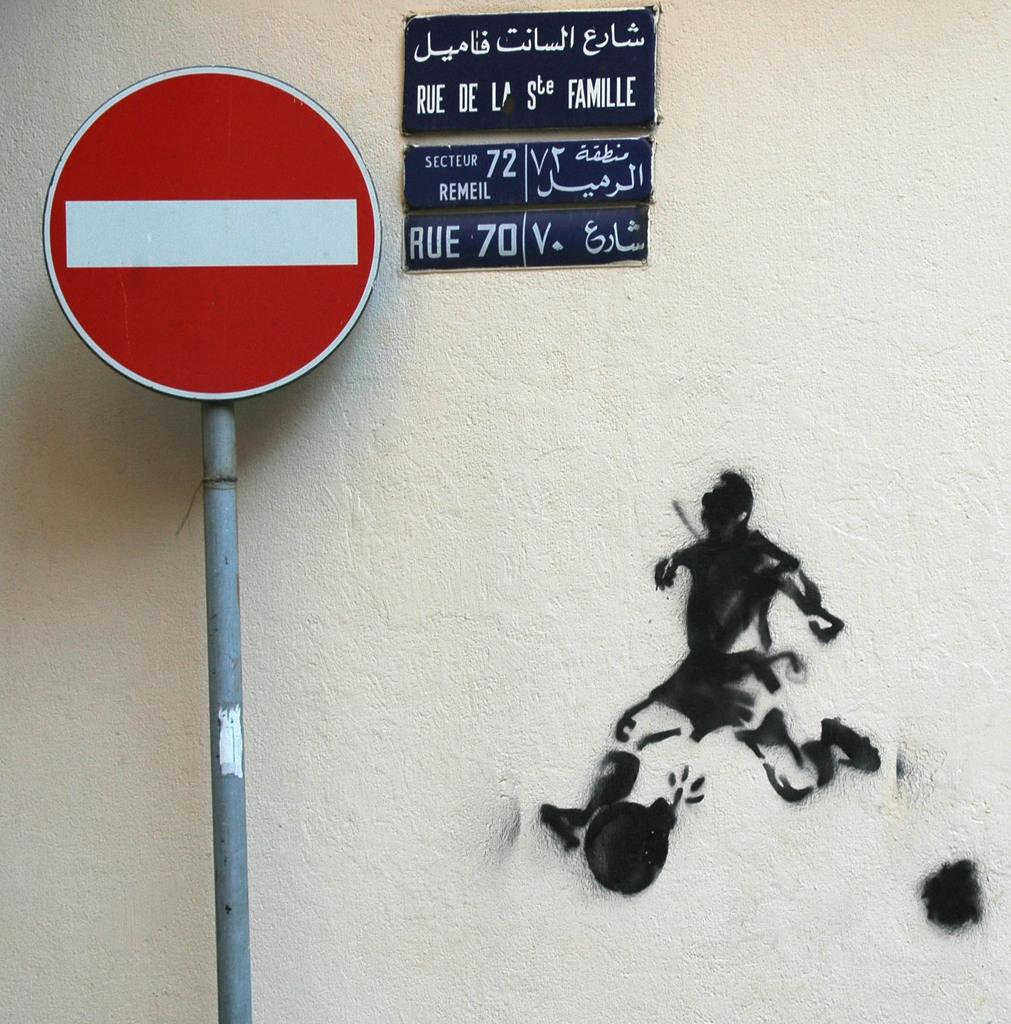What is located on a pole in the image? There is a sign board on a pole in the image. What can be seen in the background of the image? There are boards and a drawing of a person on a wall visible in the background of the image. What scent can be detected from the drawing of the person in the image? There is no mention of a scent in the image, and the drawing of the person does not emit any scent. 